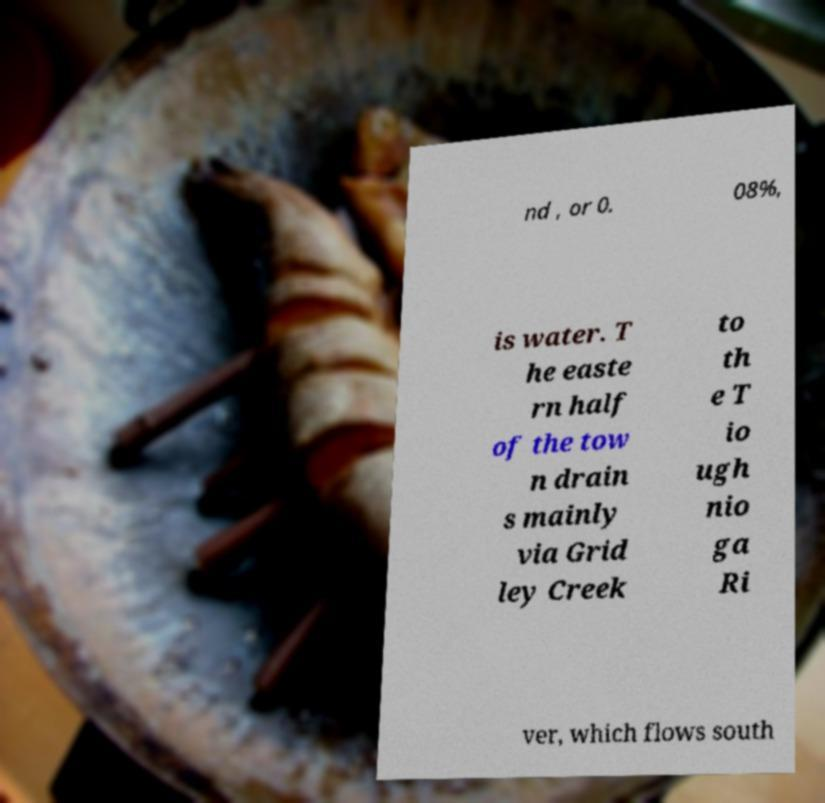For documentation purposes, I need the text within this image transcribed. Could you provide that? nd , or 0. 08%, is water. T he easte rn half of the tow n drain s mainly via Grid ley Creek to th e T io ugh nio ga Ri ver, which flows south 